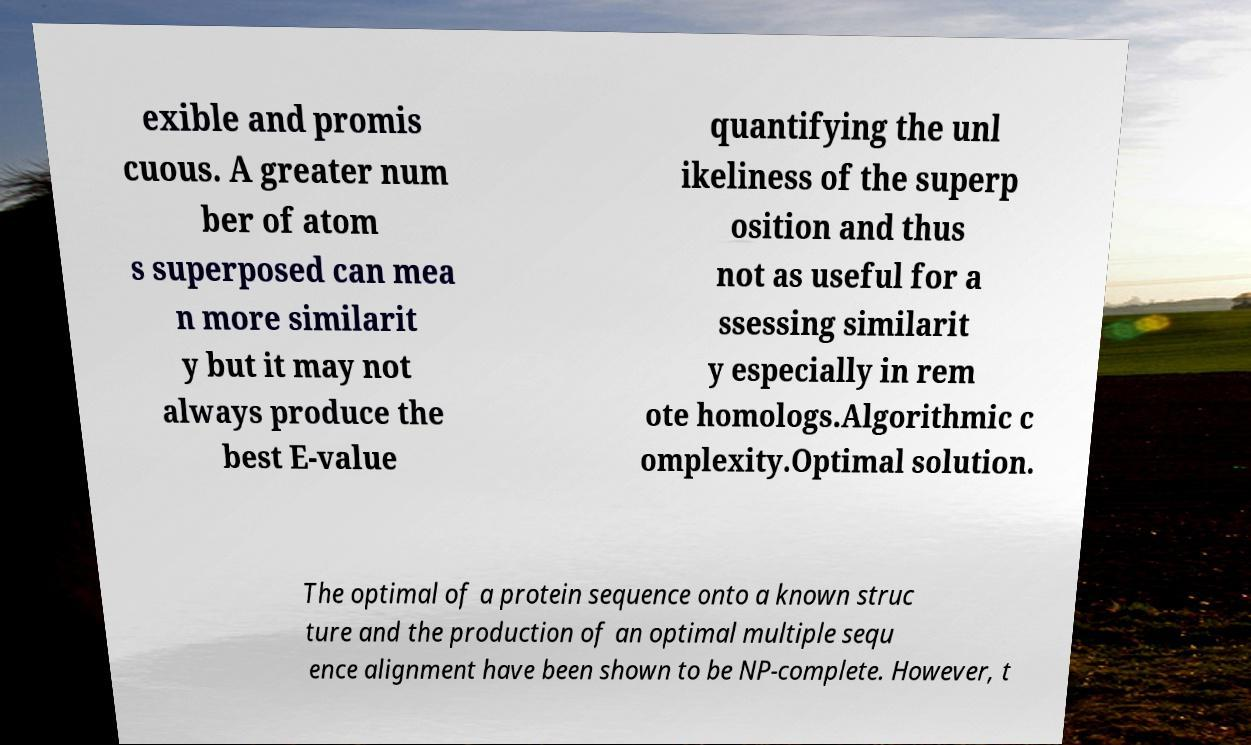Please identify and transcribe the text found in this image. exible and promis cuous. A greater num ber of atom s superposed can mea n more similarit y but it may not always produce the best E-value quantifying the unl ikeliness of the superp osition and thus not as useful for a ssessing similarit y especially in rem ote homologs.Algorithmic c omplexity.Optimal solution. The optimal of a protein sequence onto a known struc ture and the production of an optimal multiple sequ ence alignment have been shown to be NP-complete. However, t 